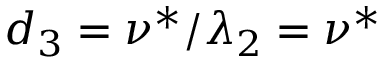<formula> <loc_0><loc_0><loc_500><loc_500>d _ { 3 } = \nu ^ { * } / \lambda _ { 2 } = \nu ^ { * }</formula> 